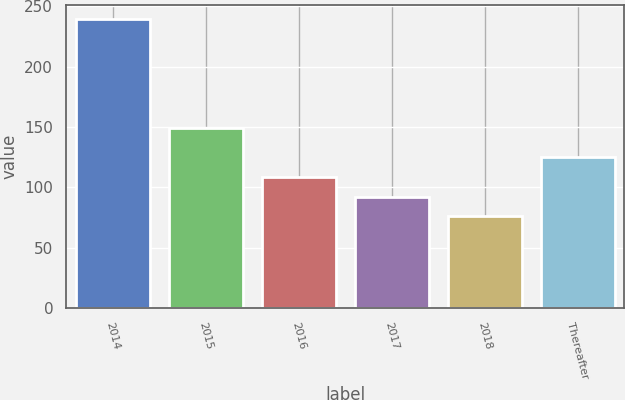<chart> <loc_0><loc_0><loc_500><loc_500><bar_chart><fcel>2014<fcel>2015<fcel>2016<fcel>2017<fcel>2018<fcel>Thereafter<nl><fcel>239<fcel>149<fcel>108.6<fcel>92.3<fcel>76<fcel>124.9<nl></chart> 